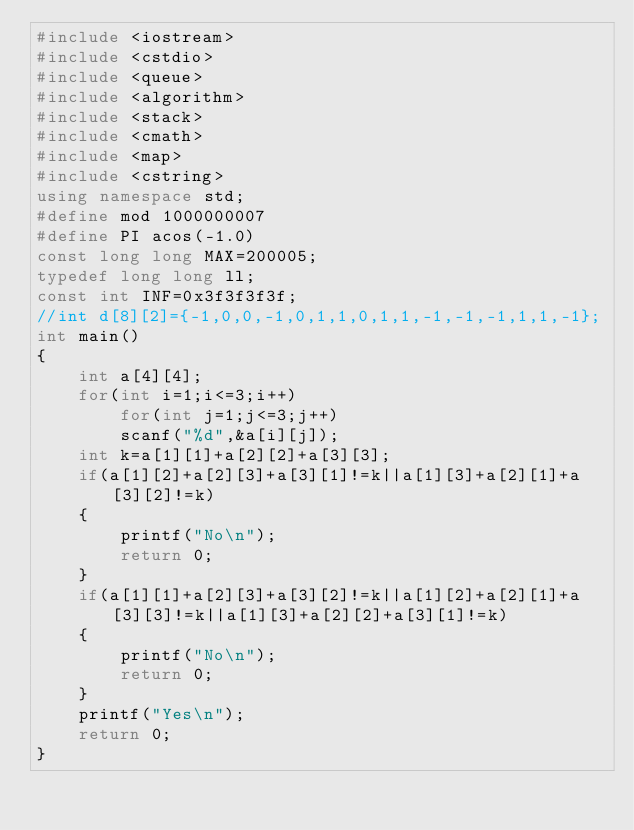<code> <loc_0><loc_0><loc_500><loc_500><_C++_>#include <iostream>
#include <cstdio>
#include <queue>
#include <algorithm>
#include <stack>
#include <cmath>
#include <map>
#include <cstring>
using namespace std;
#define mod 1000000007
#define PI acos(-1.0)
const long long MAX=200005;
typedef long long ll;
const int INF=0x3f3f3f3f;
//int d[8][2]={-1,0,0,-1,0,1,1,0,1,1,-1,-1,-1,1,1,-1};
int main()
{
    int a[4][4];
    for(int i=1;i<=3;i++)
        for(int j=1;j<=3;j++)
        scanf("%d",&a[i][j]);
    int k=a[1][1]+a[2][2]+a[3][3];
    if(a[1][2]+a[2][3]+a[3][1]!=k||a[1][3]+a[2][1]+a[3][2]!=k)
    {
        printf("No\n");
        return 0;
    }
    if(a[1][1]+a[2][3]+a[3][2]!=k||a[1][2]+a[2][1]+a[3][3]!=k||a[1][3]+a[2][2]+a[3][1]!=k)
    {
        printf("No\n");
        return 0;
    }
    printf("Yes\n");
    return 0;
}
</code> 